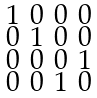<formula> <loc_0><loc_0><loc_500><loc_500>\begin{smallmatrix} 1 & 0 & 0 & 0 \\ 0 & 1 & 0 & 0 \\ 0 & 0 & 0 & 1 \\ 0 & 0 & 1 & 0 \end{smallmatrix}</formula> 